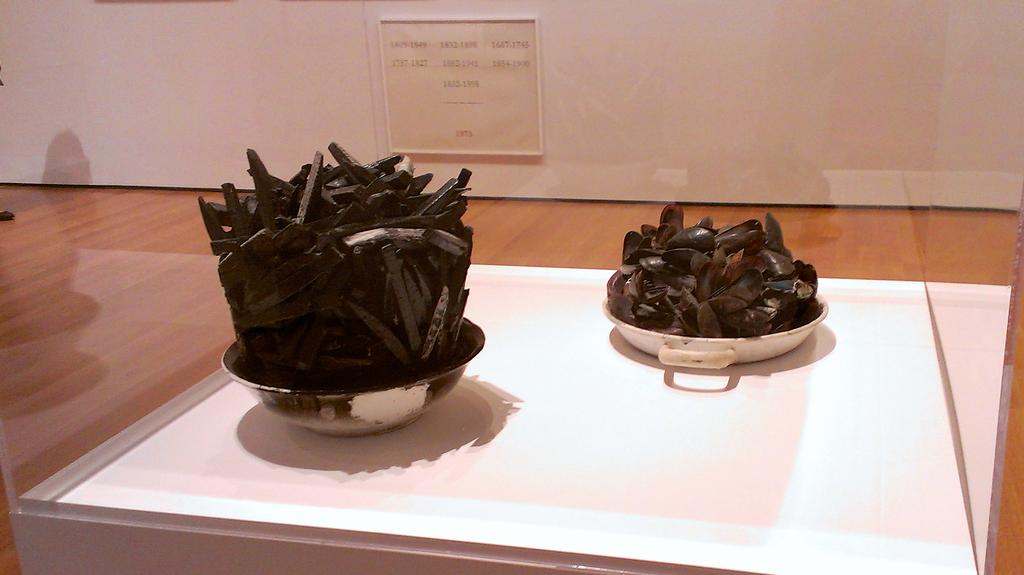What is the food item in the image contained in? The food item is in a bowl. What other object can be seen in the image? There is a display glass box in the image. What type of account is being managed in the image? There is no reference to an account in the image; it features a food item in a bowl and a display glass box. What type of metal can be seen in the image? There is no metal present in the image. 